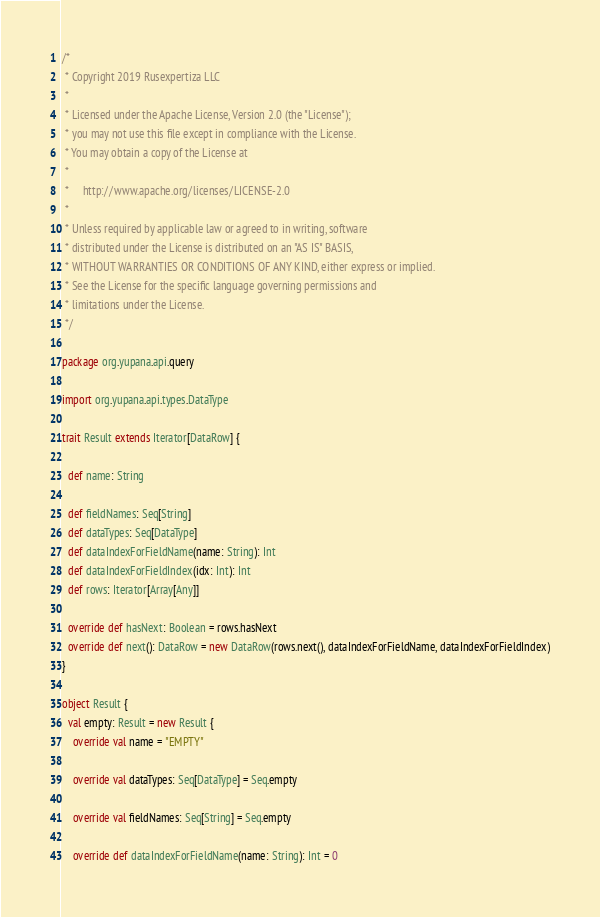<code> <loc_0><loc_0><loc_500><loc_500><_Scala_>/*
 * Copyright 2019 Rusexpertiza LLC
 *
 * Licensed under the Apache License, Version 2.0 (the "License");
 * you may not use this file except in compliance with the License.
 * You may obtain a copy of the License at
 *
 *     http://www.apache.org/licenses/LICENSE-2.0
 *
 * Unless required by applicable law or agreed to in writing, software
 * distributed under the License is distributed on an "AS IS" BASIS,
 * WITHOUT WARRANTIES OR CONDITIONS OF ANY KIND, either express or implied.
 * See the License for the specific language governing permissions and
 * limitations under the License.
 */

package org.yupana.api.query

import org.yupana.api.types.DataType

trait Result extends Iterator[DataRow] {

  def name: String

  def fieldNames: Seq[String]
  def dataTypes: Seq[DataType]
  def dataIndexForFieldName(name: String): Int
  def dataIndexForFieldIndex(idx: Int): Int
  def rows: Iterator[Array[Any]]

  override def hasNext: Boolean = rows.hasNext
  override def next(): DataRow = new DataRow(rows.next(), dataIndexForFieldName, dataIndexForFieldIndex)
}

object Result {
  val empty: Result = new Result {
    override val name = "EMPTY"

    override val dataTypes: Seq[DataType] = Seq.empty

    override val fieldNames: Seq[String] = Seq.empty

    override def dataIndexForFieldName(name: String): Int = 0
</code> 